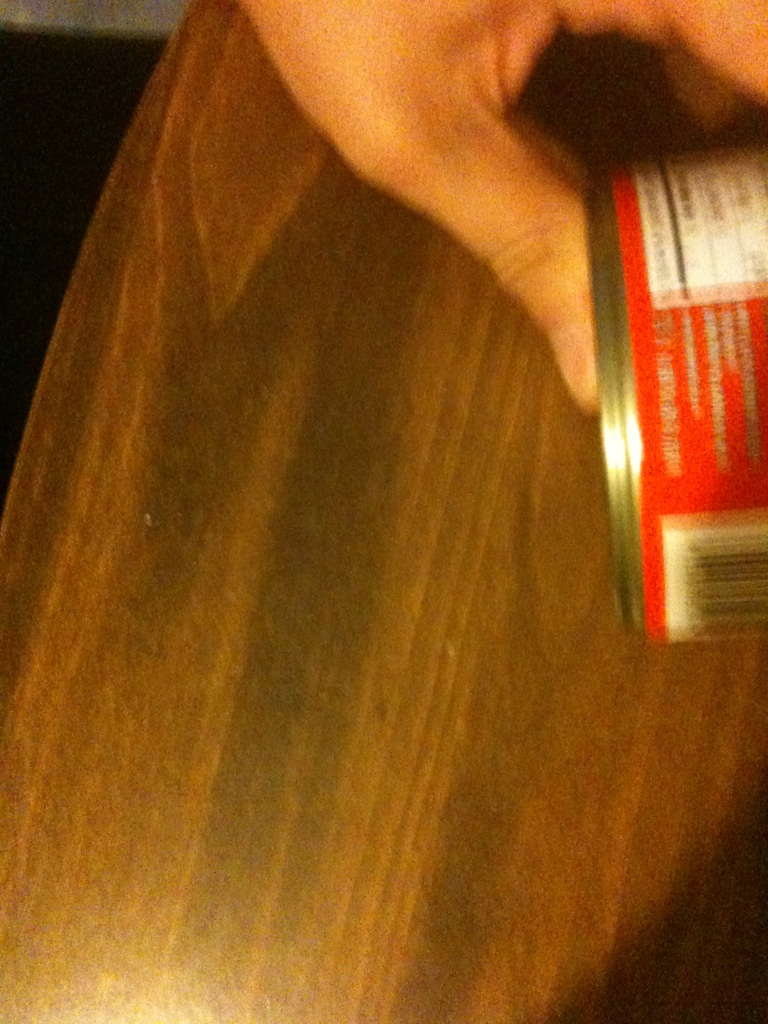What type of product could be in this can? Given the typical use of cans for packaging, it is likely the can contains a food product such as soup, vegetables, or beans. The exact contents cannot be discerned from the image quality provided. 